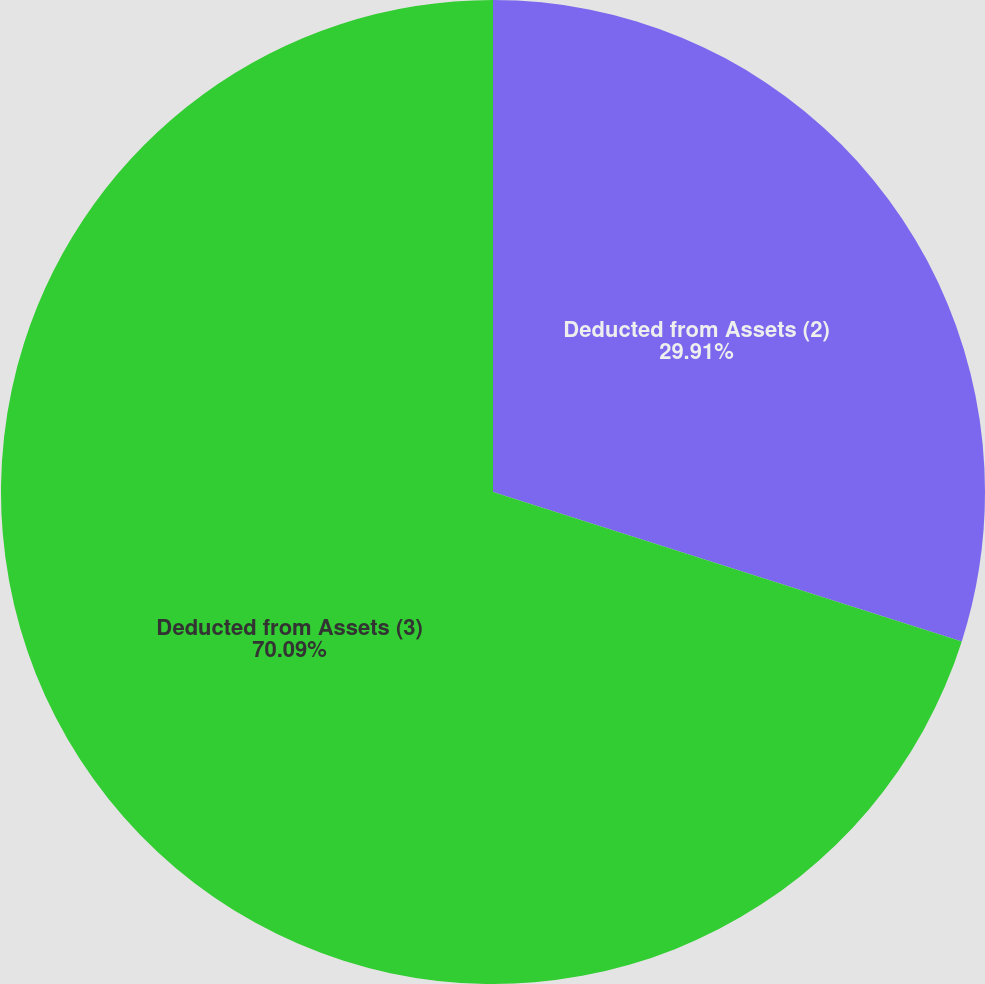<chart> <loc_0><loc_0><loc_500><loc_500><pie_chart><fcel>Deducted from Assets (2)<fcel>Deducted from Assets (3)<nl><fcel>29.91%<fcel>70.09%<nl></chart> 